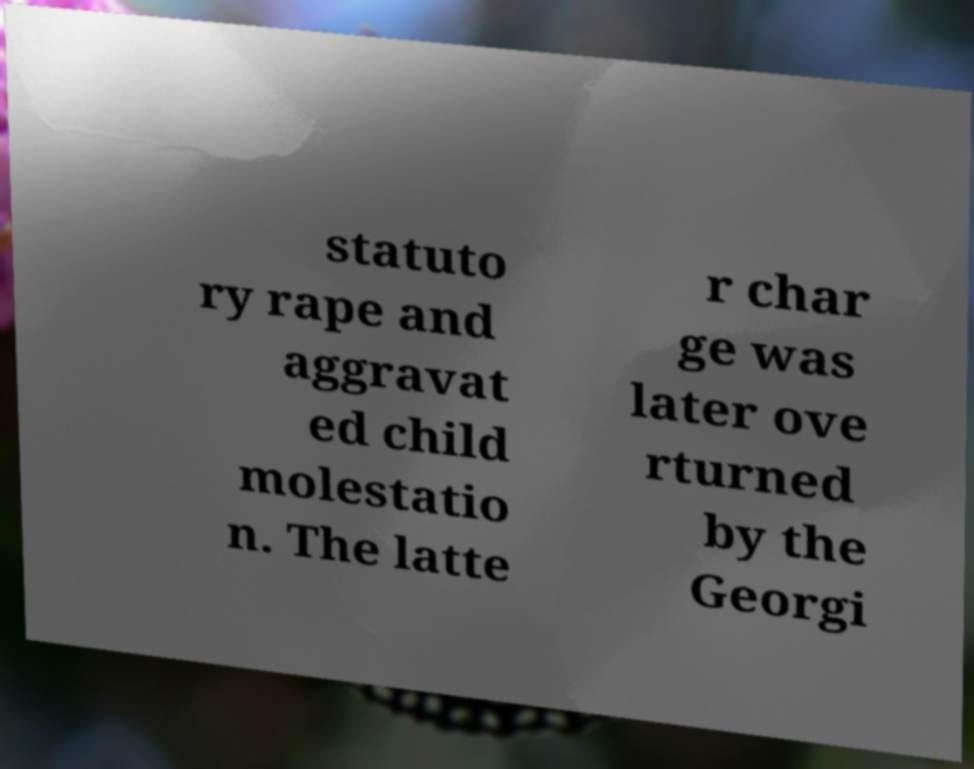There's text embedded in this image that I need extracted. Can you transcribe it verbatim? statuto ry rape and aggravat ed child molestatio n. The latte r char ge was later ove rturned by the Georgi 